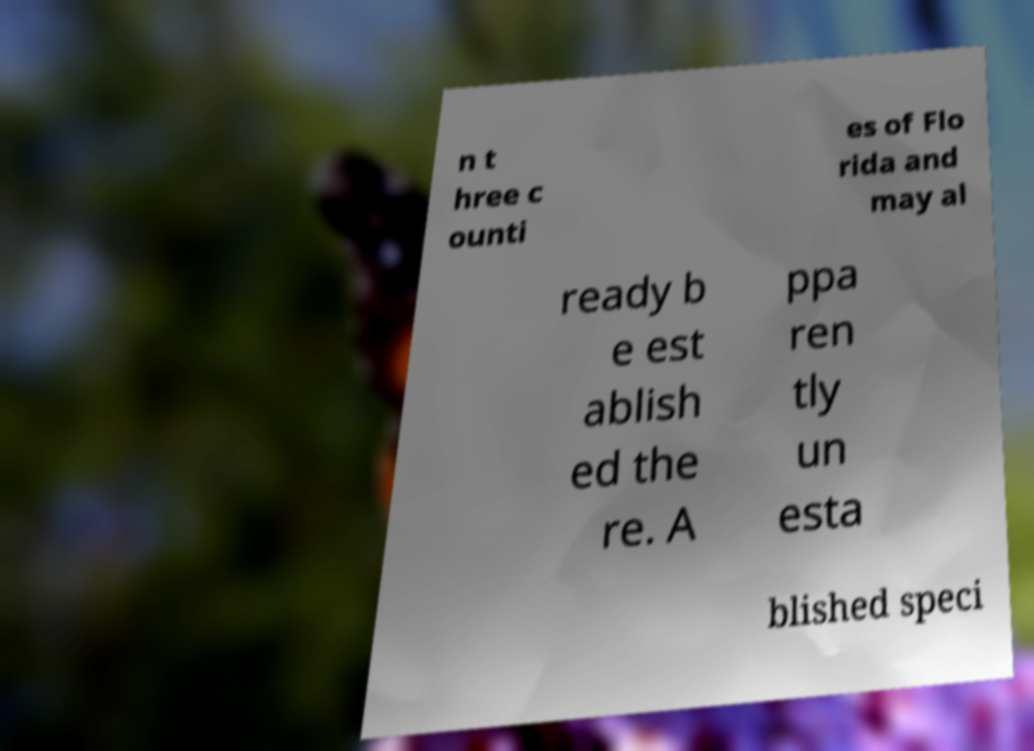Can you read and provide the text displayed in the image?This photo seems to have some interesting text. Can you extract and type it out for me? n t hree c ounti es of Flo rida and may al ready b e est ablish ed the re. A ppa ren tly un esta blished speci 